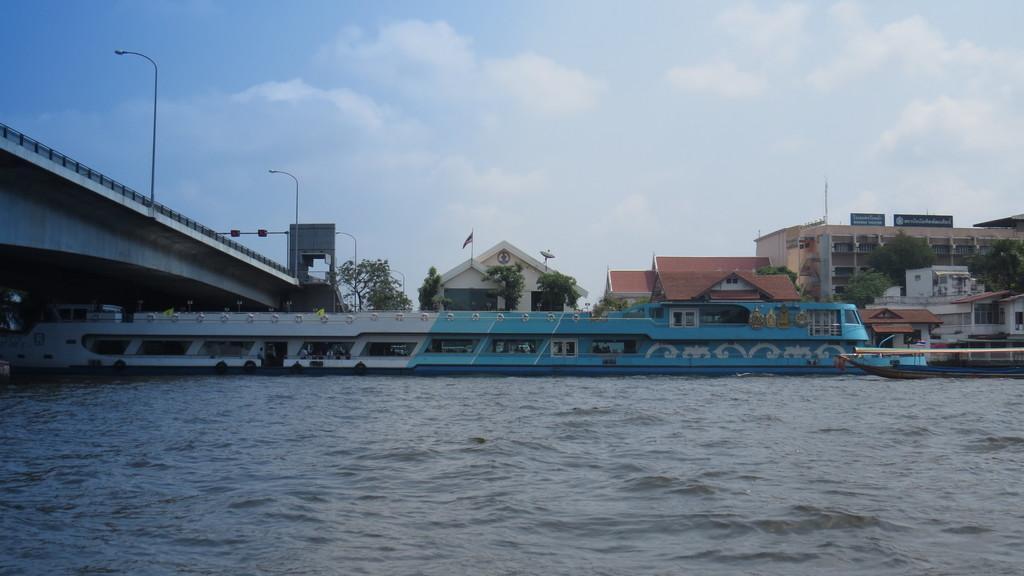Can you describe this image briefly? In the image we can see a boat, in the water. There are many trees and buildings. There is a bridge, light pole and a cloudy sky. 